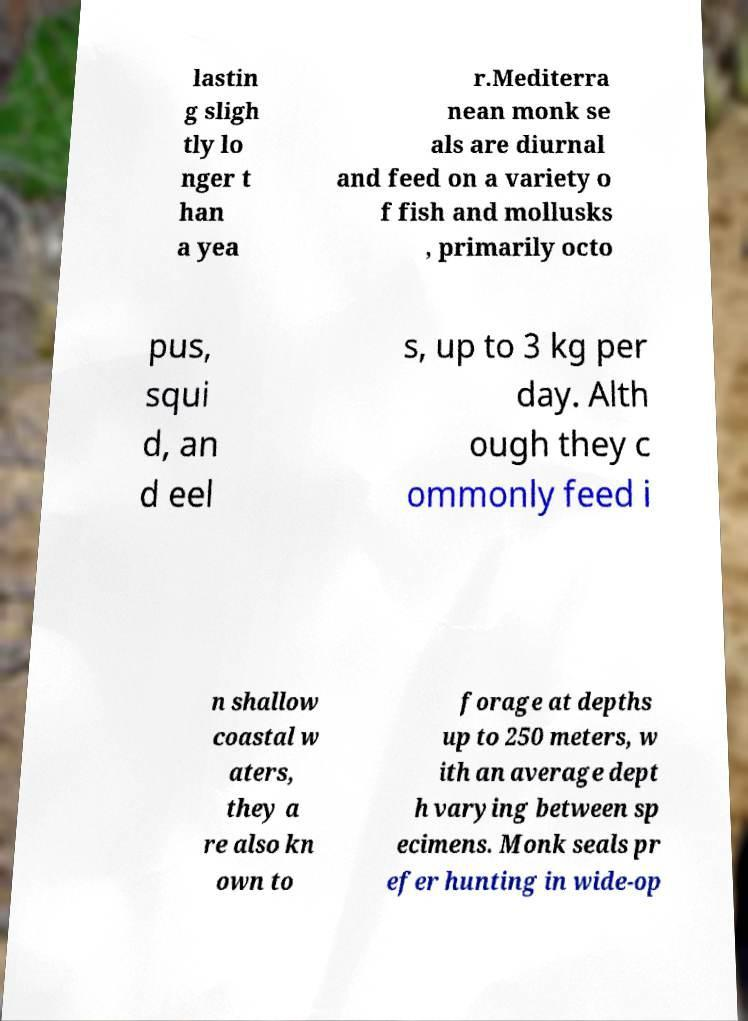Could you extract and type out the text from this image? lastin g sligh tly lo nger t han a yea r.Mediterra nean monk se als are diurnal and feed on a variety o f fish and mollusks , primarily octo pus, squi d, an d eel s, up to 3 kg per day. Alth ough they c ommonly feed i n shallow coastal w aters, they a re also kn own to forage at depths up to 250 meters, w ith an average dept h varying between sp ecimens. Monk seals pr efer hunting in wide-op 